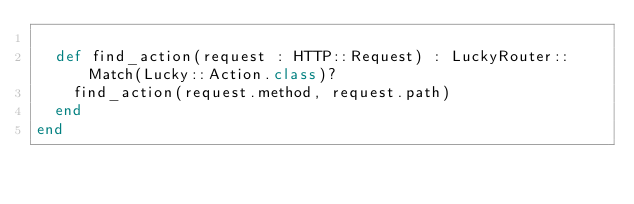Convert code to text. <code><loc_0><loc_0><loc_500><loc_500><_Crystal_>
  def find_action(request : HTTP::Request) : LuckyRouter::Match(Lucky::Action.class)?
    find_action(request.method, request.path)
  end
end
</code> 